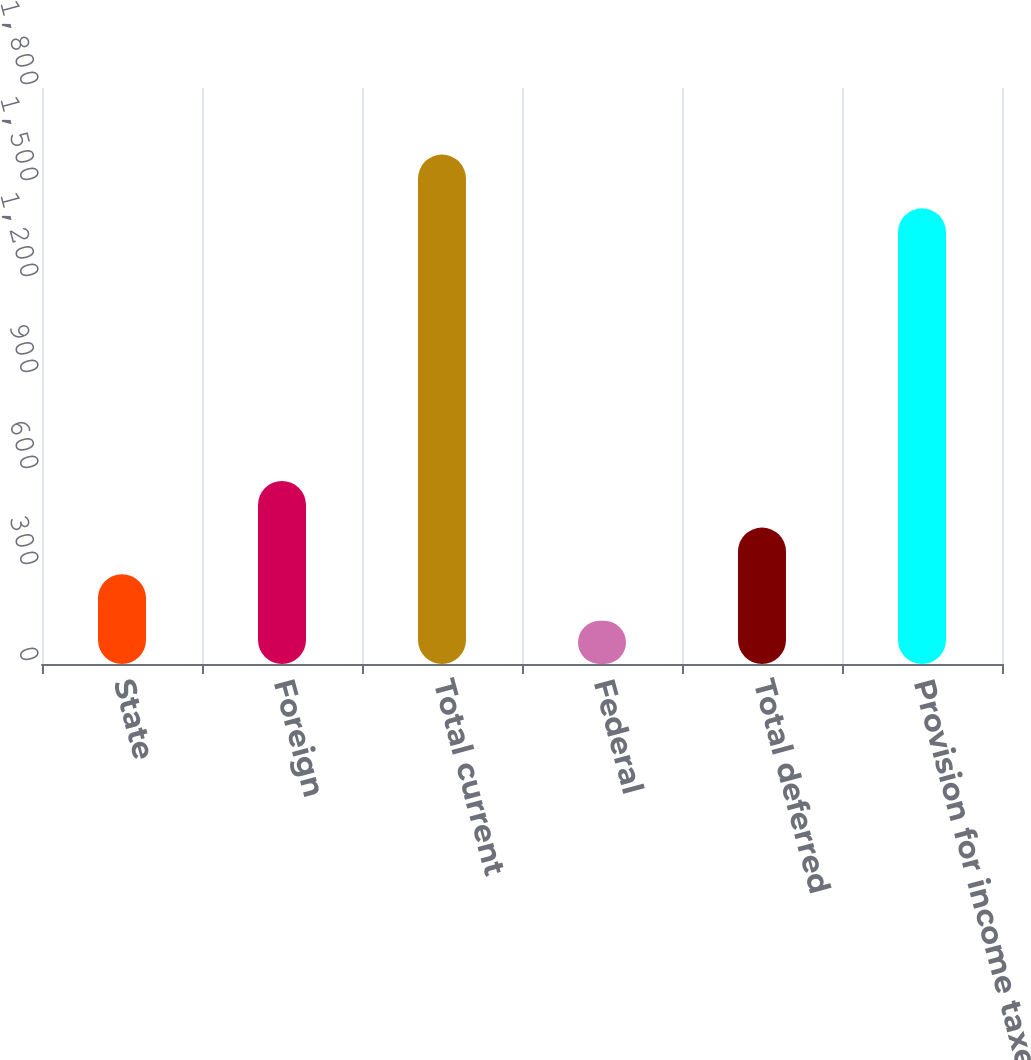<chart> <loc_0><loc_0><loc_500><loc_500><bar_chart><fcel>State<fcel>Foreign<fcel>Total current<fcel>Federal<fcel>Total deferred<fcel>Provision for income taxes<nl><fcel>280.7<fcel>572.1<fcel>1592<fcel>135<fcel>426.4<fcel>1424<nl></chart> 